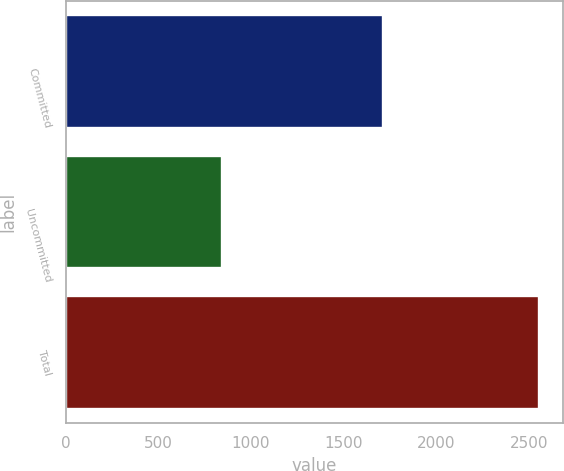Convert chart. <chart><loc_0><loc_0><loc_500><loc_500><bar_chart><fcel>Committed<fcel>Uncommitted<fcel>Total<nl><fcel>1712<fcel>842<fcel>2554<nl></chart> 